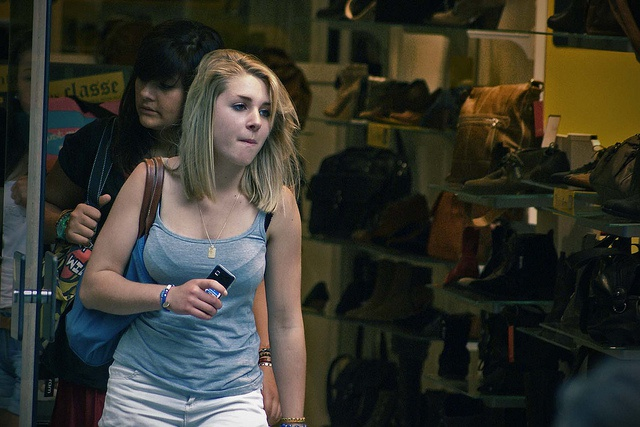Describe the objects in this image and their specific colors. I can see people in black, gray, darkgray, and blue tones, people in black, gray, and maroon tones, handbag in black and darkgreen tones, handbag in black, maroon, and darkgreen tones, and handbag in black tones in this image. 